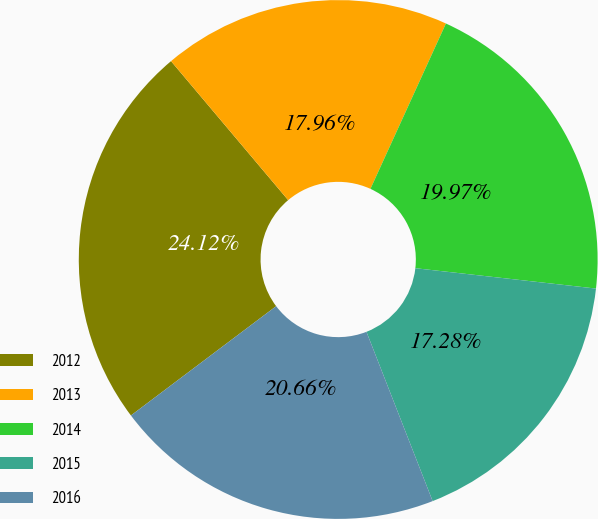<chart> <loc_0><loc_0><loc_500><loc_500><pie_chart><fcel>2012<fcel>2013<fcel>2014<fcel>2015<fcel>2016<nl><fcel>24.12%<fcel>17.96%<fcel>19.97%<fcel>17.28%<fcel>20.66%<nl></chart> 